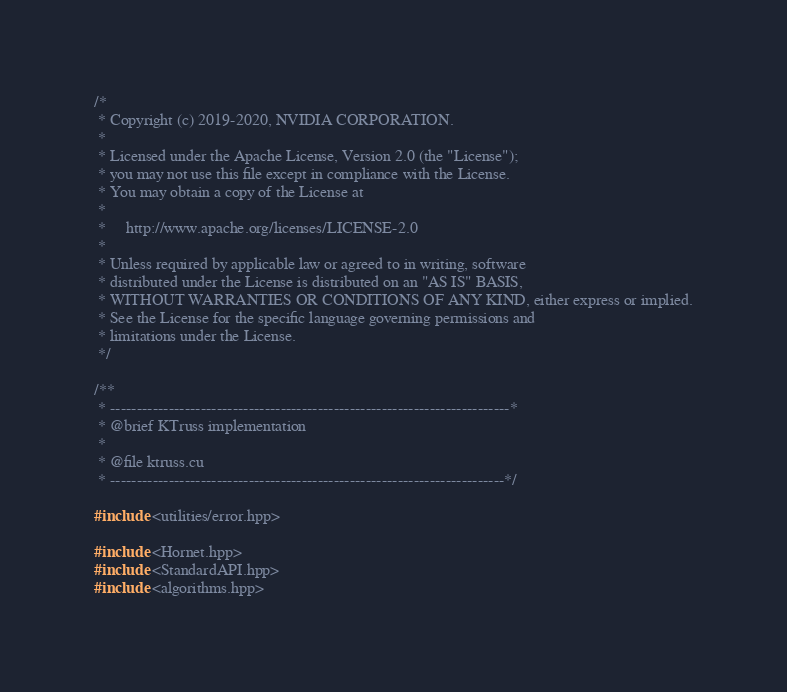Convert code to text. <code><loc_0><loc_0><loc_500><loc_500><_Cuda_>/*
 * Copyright (c) 2019-2020, NVIDIA CORPORATION.
 *
 * Licensed under the Apache License, Version 2.0 (the "License");
 * you may not use this file except in compliance with the License.
 * You may obtain a copy of the License at
 *
 *     http://www.apache.org/licenses/LICENSE-2.0
 *
 * Unless required by applicable law or agreed to in writing, software
 * distributed under the License is distributed on an "AS IS" BASIS,
 * WITHOUT WARRANTIES OR CONDITIONS OF ANY KIND, either express or implied.
 * See the License for the specific language governing permissions and
 * limitations under the License.
 */

/**
 * ---------------------------------------------------------------------------*
 * @brief KTruss implementation
 *
 * @file ktruss.cu
 * --------------------------------------------------------------------------*/

#include <utilities/error.hpp>

#include <Hornet.hpp>
#include <StandardAPI.hpp>
#include <algorithms.hpp></code> 